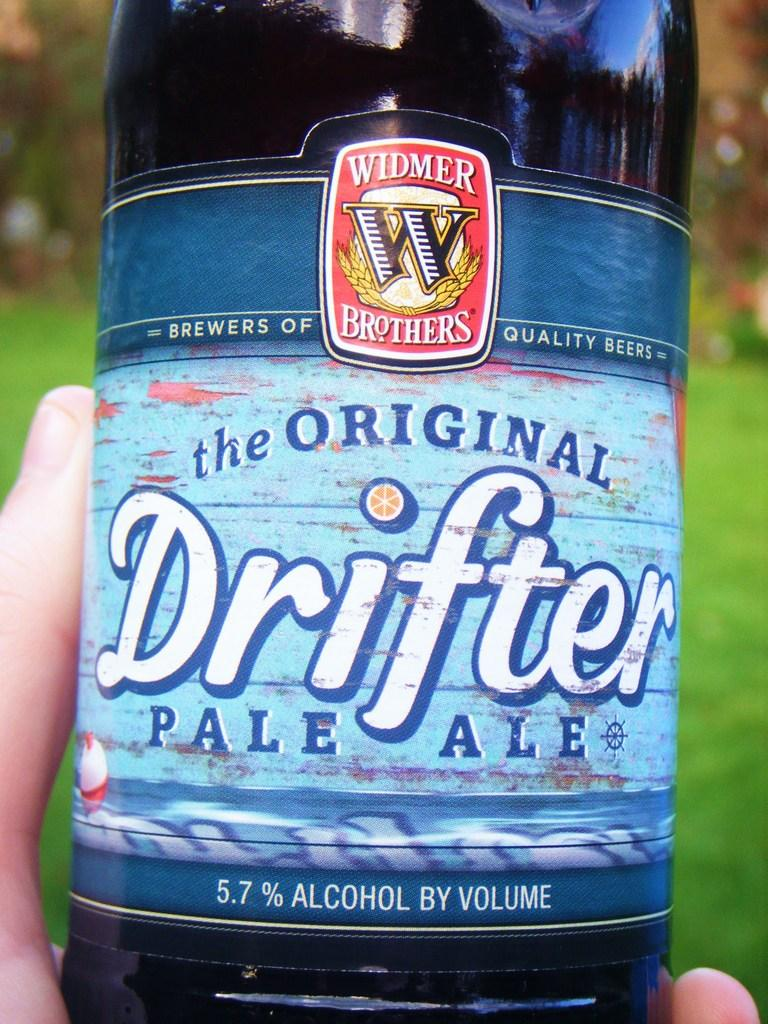Provide a one-sentence caption for the provided image. The original drifer pale ale is in somebody hand. 